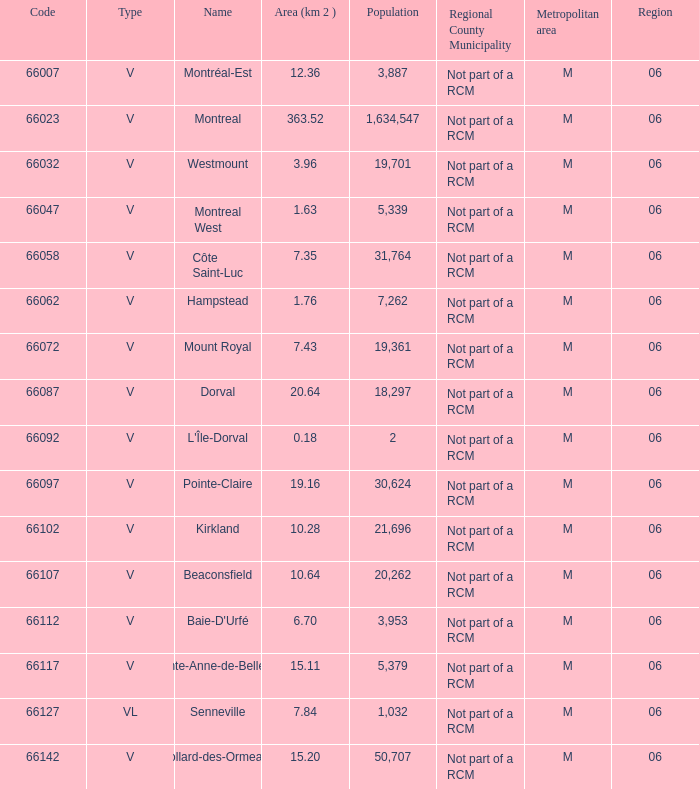Identify the most extensive zone having a code below 66112 and a name known as l'île-dorval? 6.0. 